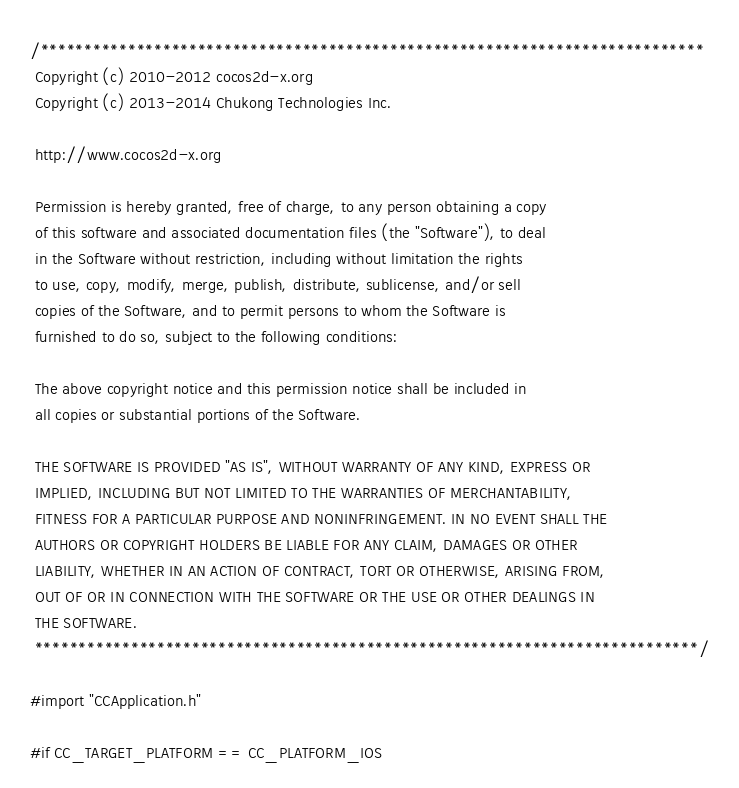Convert code to text. <code><loc_0><loc_0><loc_500><loc_500><_ObjectiveC_>/****************************************************************************
 Copyright (c) 2010-2012 cocos2d-x.org
 Copyright (c) 2013-2014 Chukong Technologies Inc.
 
 http://www.cocos2d-x.org
 
 Permission is hereby granted, free of charge, to any person obtaining a copy
 of this software and associated documentation files (the "Software"), to deal
 in the Software without restriction, including without limitation the rights
 to use, copy, modify, merge, publish, distribute, sublicense, and/or sell
 copies of the Software, and to permit persons to whom the Software is
 furnished to do so, subject to the following conditions:
 
 The above copyright notice and this permission notice shall be included in
 all copies or substantial portions of the Software.
 
 THE SOFTWARE IS PROVIDED "AS IS", WITHOUT WARRANTY OF ANY KIND, EXPRESS OR
 IMPLIED, INCLUDING BUT NOT LIMITED TO THE WARRANTIES OF MERCHANTABILITY,
 FITNESS FOR A PARTICULAR PURPOSE AND NONINFRINGEMENT. IN NO EVENT SHALL THE
 AUTHORS OR COPYRIGHT HOLDERS BE LIABLE FOR ANY CLAIM, DAMAGES OR OTHER
 LIABILITY, WHETHER IN AN ACTION OF CONTRACT, TORT OR OTHERWISE, ARISING FROM,
 OUT OF OR IN CONNECTION WITH THE SOFTWARE OR THE USE OR OTHER DEALINGS IN
 THE SOFTWARE.
 ****************************************************************************/

#import "CCApplication.h"

#if CC_TARGET_PLATFORM == CC_PLATFORM_IOS
</code> 